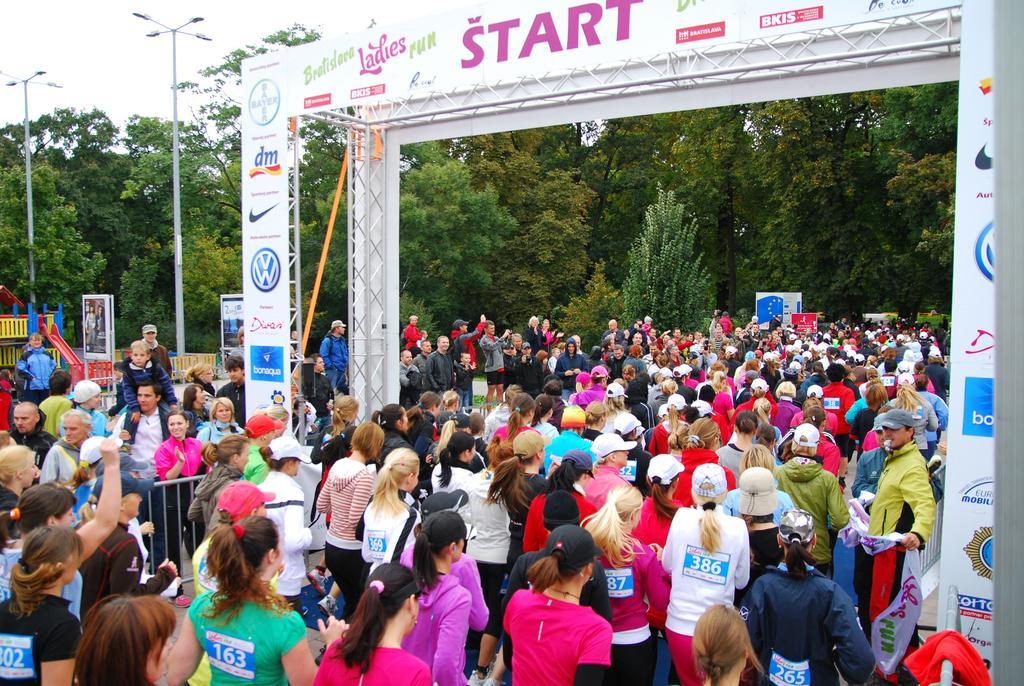How would you summarize this image in a sentence or two? A group of women are walking through this entrance in the long back side there are trees. 